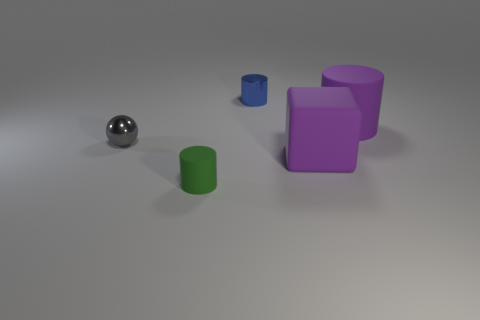Are there an equal number of big purple rubber cubes behind the gray shiny sphere and large purple things that are in front of the large rubber cylinder?
Provide a short and direct response. No. What is the shape of the object that is the same size as the cube?
Your response must be concise. Cylinder. Is there a tiny object that has the same color as the big cylinder?
Ensure brevity in your answer.  No. What is the shape of the thing that is left of the small matte cylinder?
Provide a short and direct response. Sphere. What is the color of the large matte block?
Offer a terse response. Purple. What color is the cylinder that is made of the same material as the gray sphere?
Offer a very short reply. Blue. How many tiny red things have the same material as the purple block?
Offer a very short reply. 0. There is a tiny blue metallic object; what number of small matte cylinders are behind it?
Ensure brevity in your answer.  0. Do the object on the right side of the big cube and the tiny cylinder that is behind the gray shiny thing have the same material?
Provide a short and direct response. No. Are there more small metal cylinders in front of the big matte cube than rubber cylinders on the right side of the small green matte cylinder?
Provide a short and direct response. No. 